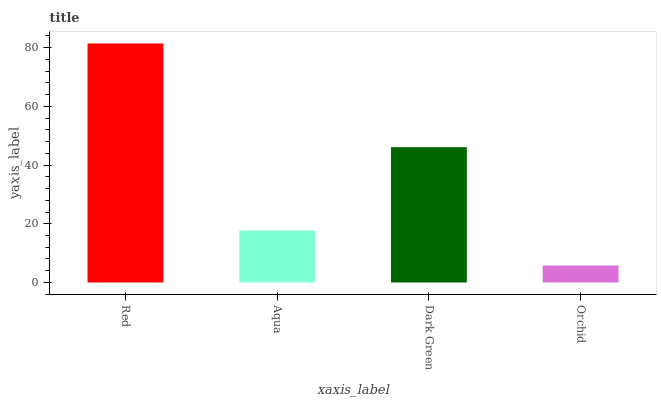Is Orchid the minimum?
Answer yes or no. Yes. Is Red the maximum?
Answer yes or no. Yes. Is Aqua the minimum?
Answer yes or no. No. Is Aqua the maximum?
Answer yes or no. No. Is Red greater than Aqua?
Answer yes or no. Yes. Is Aqua less than Red?
Answer yes or no. Yes. Is Aqua greater than Red?
Answer yes or no. No. Is Red less than Aqua?
Answer yes or no. No. Is Dark Green the high median?
Answer yes or no. Yes. Is Aqua the low median?
Answer yes or no. Yes. Is Orchid the high median?
Answer yes or no. No. Is Dark Green the low median?
Answer yes or no. No. 